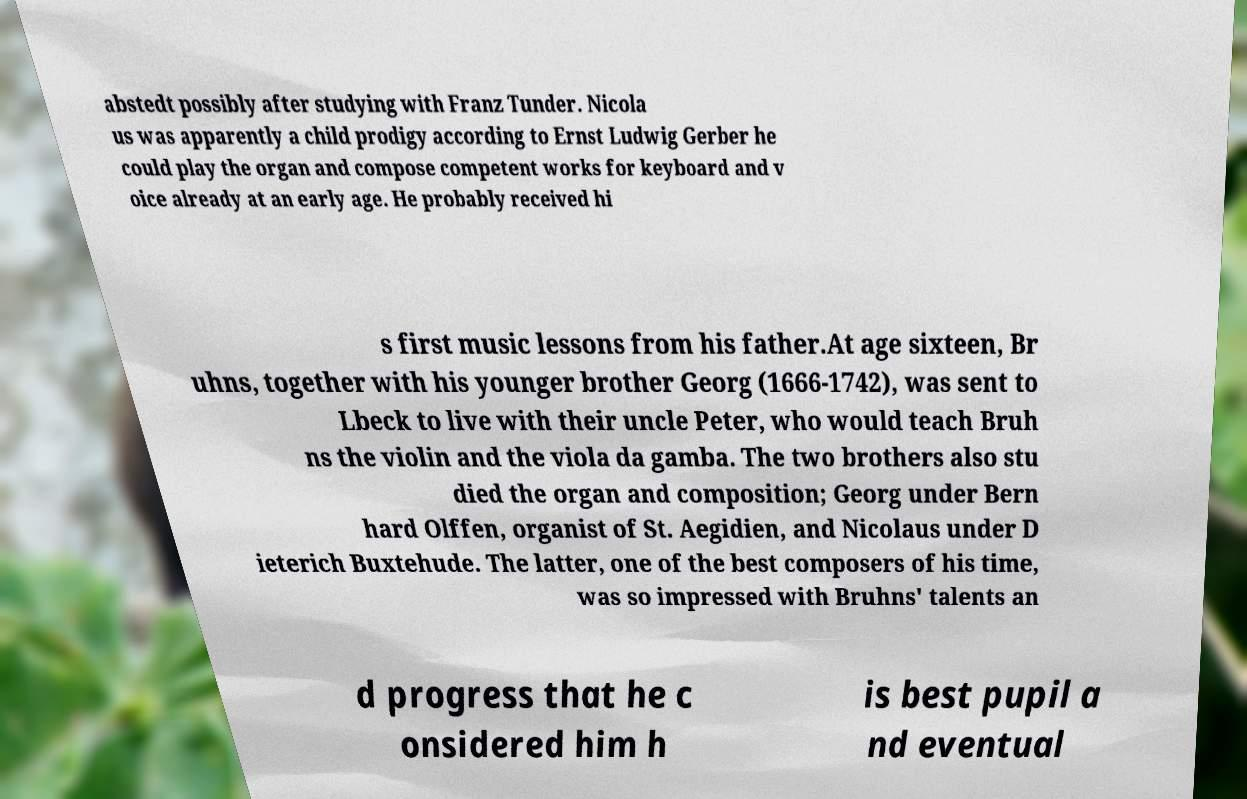Could you assist in decoding the text presented in this image and type it out clearly? abstedt possibly after studying with Franz Tunder. Nicola us was apparently a child prodigy according to Ernst Ludwig Gerber he could play the organ and compose competent works for keyboard and v oice already at an early age. He probably received hi s first music lessons from his father.At age sixteen, Br uhns, together with his younger brother Georg (1666-1742), was sent to Lbeck to live with their uncle Peter, who would teach Bruh ns the violin and the viola da gamba. The two brothers also stu died the organ and composition; Georg under Bern hard Olffen, organist of St. Aegidien, and Nicolaus under D ieterich Buxtehude. The latter, one of the best composers of his time, was so impressed with Bruhns' talents an d progress that he c onsidered him h is best pupil a nd eventual 